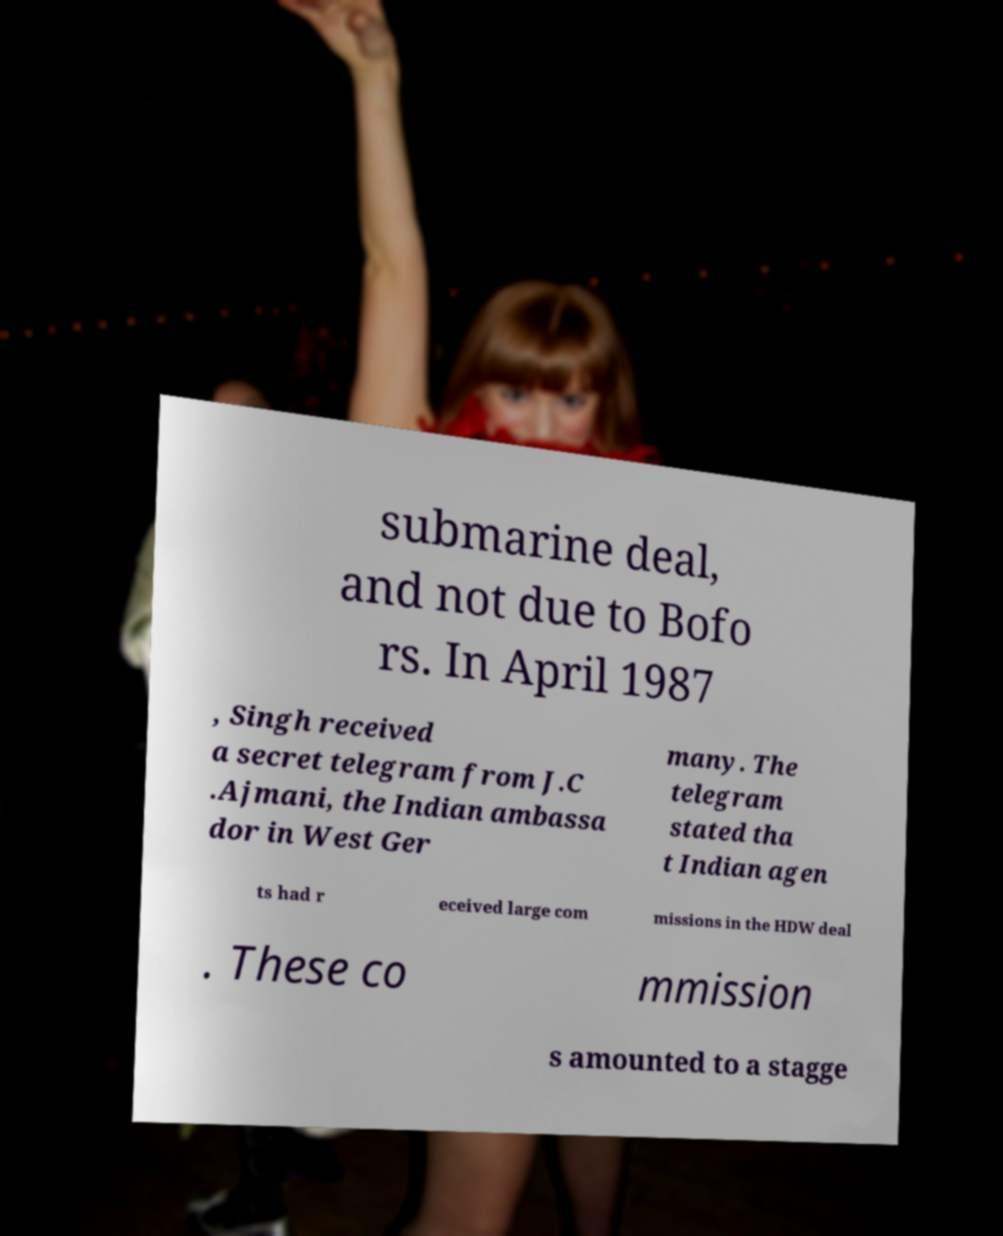Please identify and transcribe the text found in this image. submarine deal, and not due to Bofo rs. In April 1987 , Singh received a secret telegram from J.C .Ajmani, the Indian ambassa dor in West Ger many. The telegram stated tha t Indian agen ts had r eceived large com missions in the HDW deal . These co mmission s amounted to a stagge 